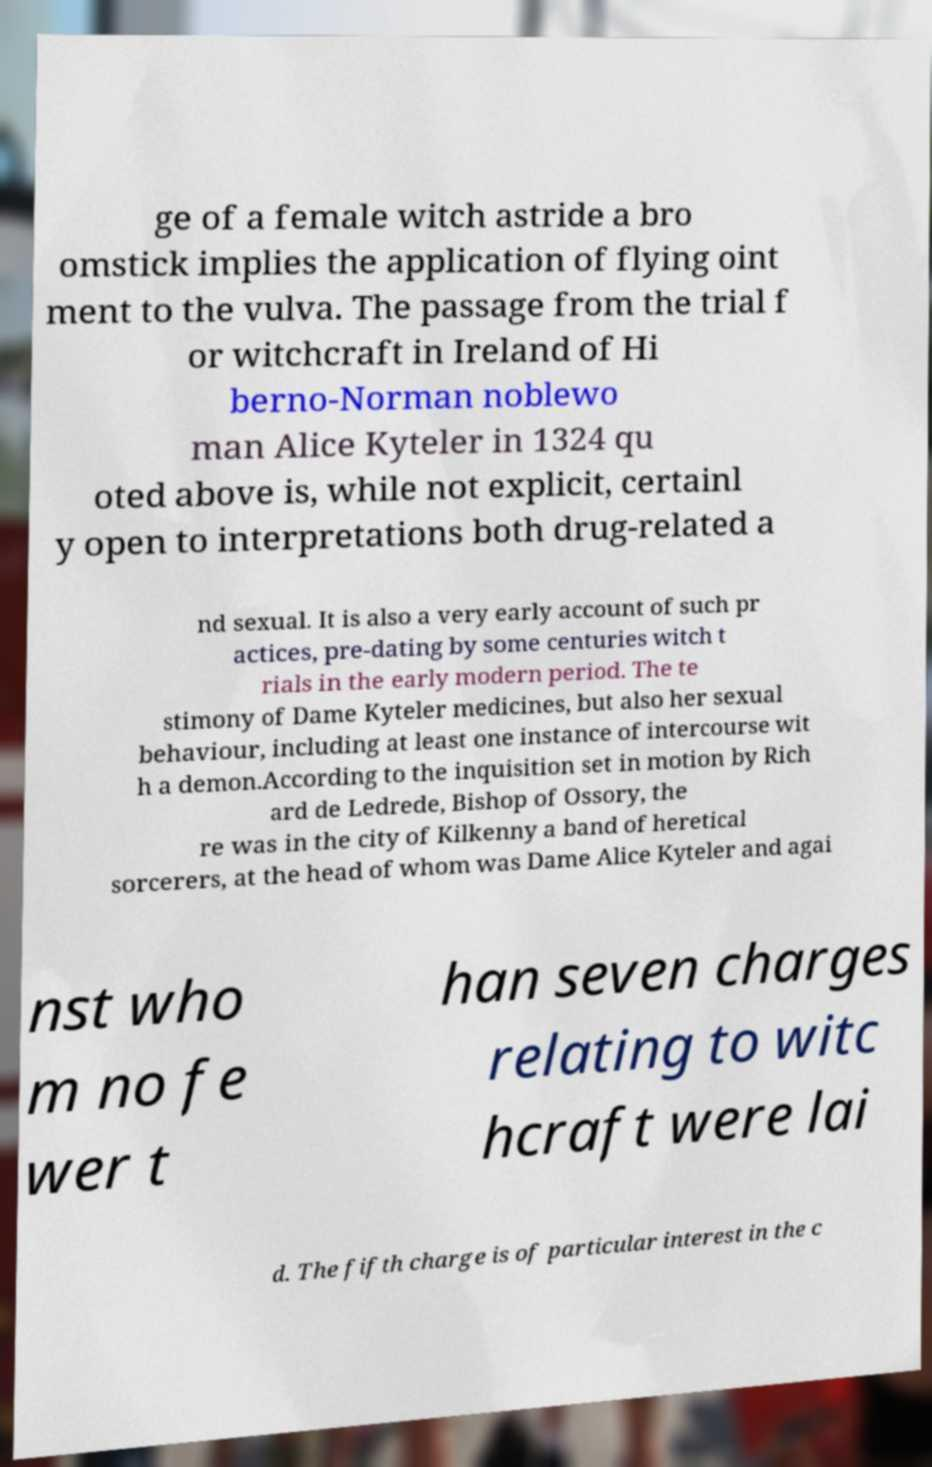Please identify and transcribe the text found in this image. ge of a female witch astride a bro omstick implies the application of flying oint ment to the vulva. The passage from the trial f or witchcraft in Ireland of Hi berno-Norman noblewo man Alice Kyteler in 1324 qu oted above is, while not explicit, certainl y open to interpretations both drug-related a nd sexual. It is also a very early account of such pr actices, pre-dating by some centuries witch t rials in the early modern period. The te stimony of Dame Kyteler medicines, but also her sexual behaviour, including at least one instance of intercourse wit h a demon.According to the inquisition set in motion by Rich ard de Ledrede, Bishop of Ossory, the re was in the city of Kilkenny a band of heretical sorcerers, at the head of whom was Dame Alice Kyteler and agai nst who m no fe wer t han seven charges relating to witc hcraft were lai d. The fifth charge is of particular interest in the c 